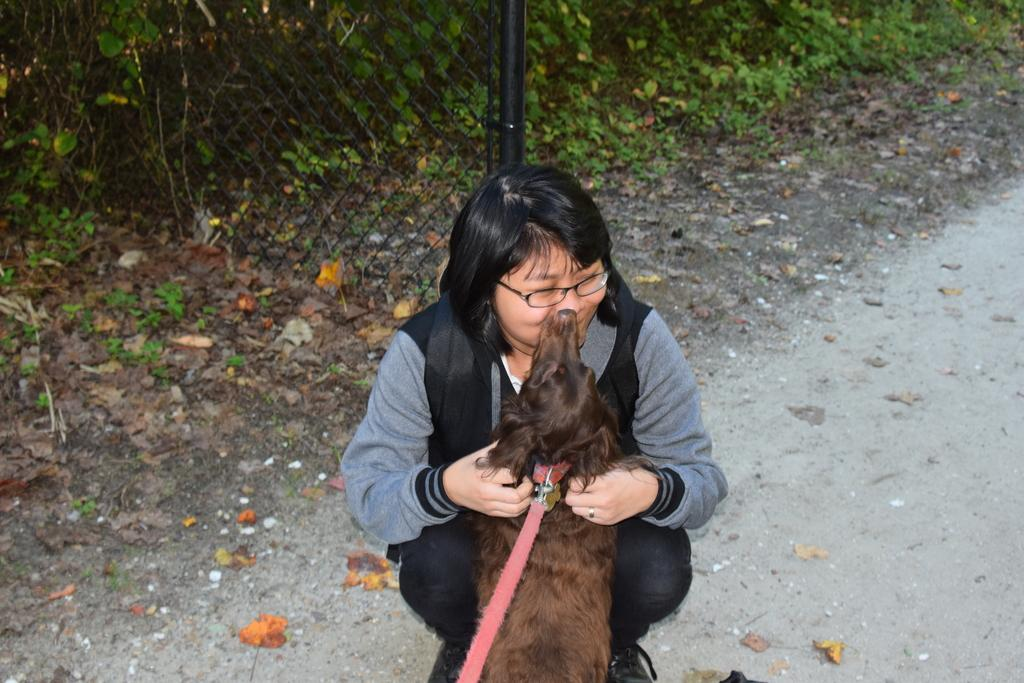What type of vegetation can be seen in the image? There are trees in the image. What structure is present in the image? There is a fence in the image. What is unusual about the road in the image? There are leaves on the road in the image. What is the woman in the image doing? The woman is sitting in the image. What is the woman wearing? The woman is wearing a black dress. What is the woman holding in the image? The woman is holding a dog. Can you see a porter carrying luggage in the image? There is no porter carrying luggage in the image. Is there a veil covering the woman's face in the image? The woman is not wearing a veil in the image; she is wearing a black dress. How many robins are perched on the fence in the image? There are no robins present in the image. 